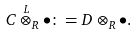<formula> <loc_0><loc_0><loc_500><loc_500>C \overset { L } { \otimes } _ { R } \bullet \colon = D \otimes _ { R } \bullet .</formula> 